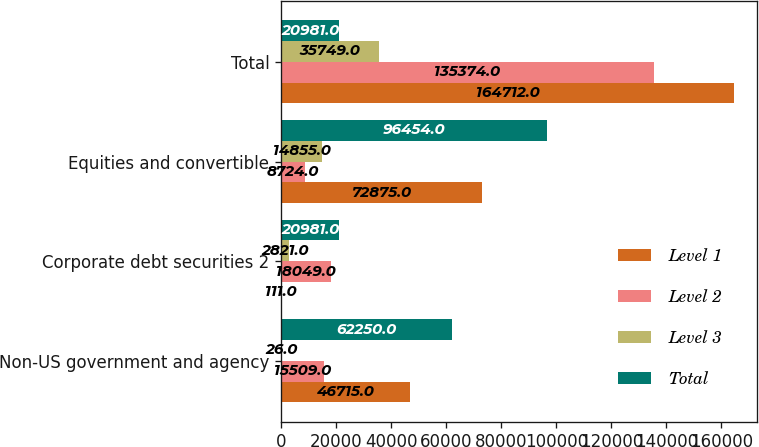Convert chart to OTSL. <chart><loc_0><loc_0><loc_500><loc_500><stacked_bar_chart><ecel><fcel>Non-US government and agency<fcel>Corporate debt securities 2<fcel>Equities and convertible<fcel>Total<nl><fcel>Level 1<fcel>46715<fcel>111<fcel>72875<fcel>164712<nl><fcel>Level 2<fcel>15509<fcel>18049<fcel>8724<fcel>135374<nl><fcel>Level 3<fcel>26<fcel>2821<fcel>14855<fcel>35749<nl><fcel>Total<fcel>62250<fcel>20981<fcel>96454<fcel>20981<nl></chart> 